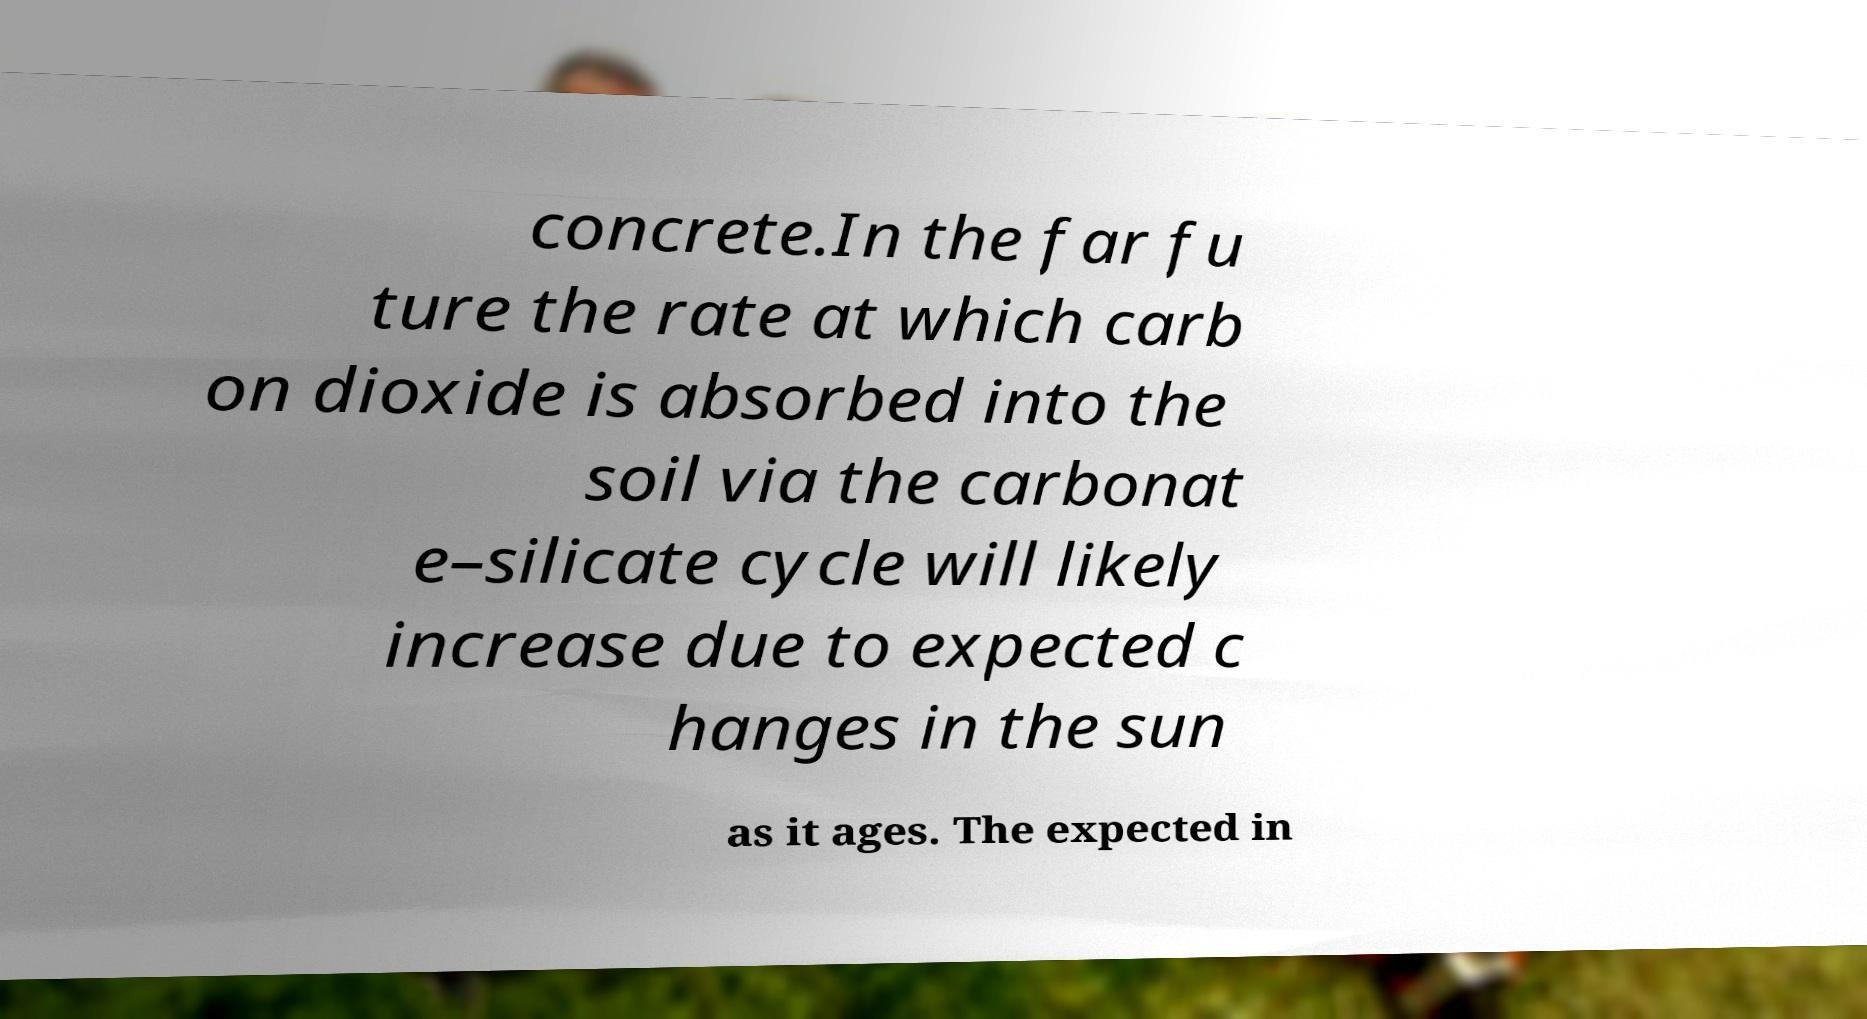Can you read and provide the text displayed in the image?This photo seems to have some interesting text. Can you extract and type it out for me? concrete.In the far fu ture the rate at which carb on dioxide is absorbed into the soil via the carbonat e–silicate cycle will likely increase due to expected c hanges in the sun as it ages. The expected in 